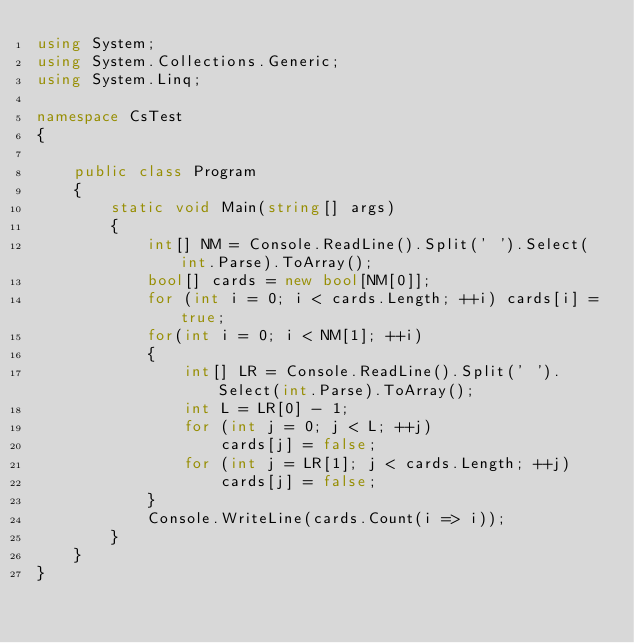<code> <loc_0><loc_0><loc_500><loc_500><_C#_>using System;
using System.Collections.Generic;
using System.Linq;

namespace CsTest
{
   
    public class Program
    {
        static void Main(string[] args)
        {
            int[] NM = Console.ReadLine().Split(' ').Select(int.Parse).ToArray();
            bool[] cards = new bool[NM[0]];
            for (int i = 0; i < cards.Length; ++i) cards[i] = true;
            for(int i = 0; i < NM[1]; ++i)
            {
                int[] LR = Console.ReadLine().Split(' ').Select(int.Parse).ToArray();
                int L = LR[0] - 1;
                for (int j = 0; j < L; ++j)
                    cards[j] = false;
                for (int j = LR[1]; j < cards.Length; ++j)
                    cards[j] = false;
            }
            Console.WriteLine(cards.Count(i => i));
        }
    }
}
</code> 